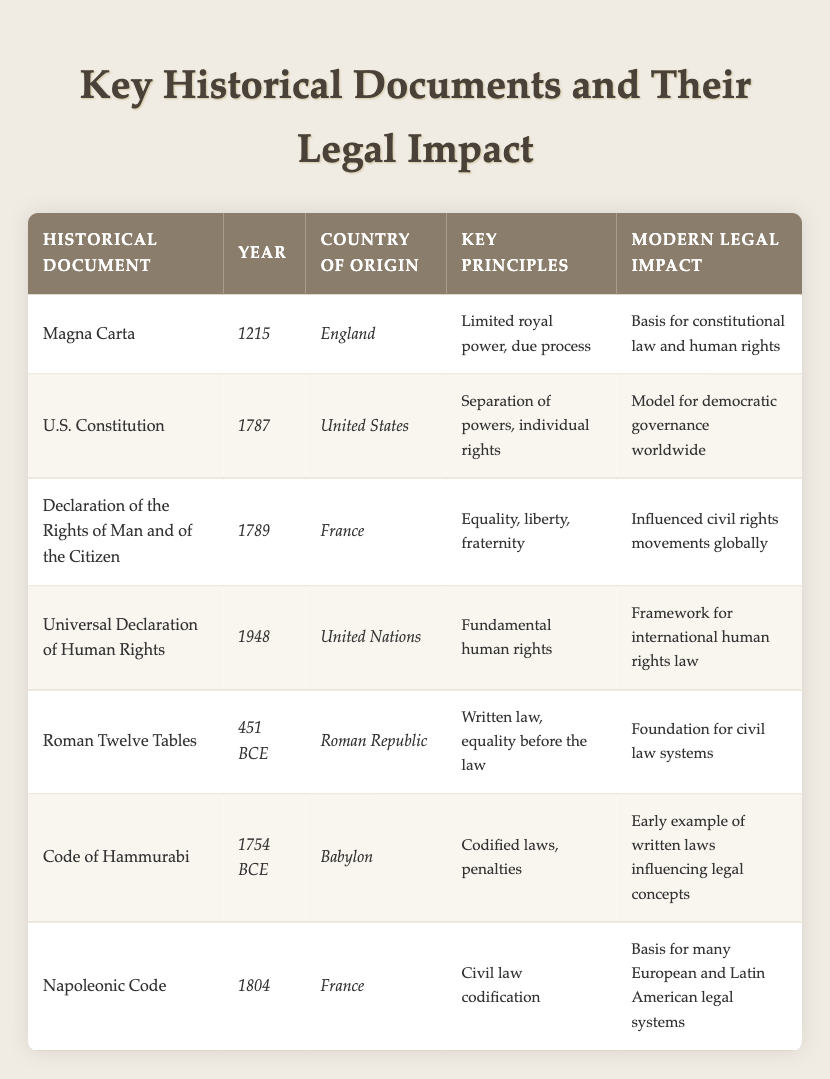What year was the Magna Carta signed? The table states that the Magna Carta was signed in 1215 under the "Year" column.
Answer: 1215 Which document is considered the basis for constitutional law and human rights? According to the "Modern Legal Impact" column, the Magna Carta is regarded as the basis for constitutional law and human rights.
Answer: Magna Carta What are the key principles of the U.S. Constitution? The "Key Principles" column shows that the U.S. Constitution is characterized by the separation of powers and individual rights.
Answer: Separation of powers, individual rights Which document was created first, the Roman Twelve Tables or the Code of Hammurabi? The table indicates that the Roman Twelve Tables were established in 451 BCE, while the Code of Hammurabi was created in 1754 BCE, making the Roman Twelve Tables the earlier document.
Answer: Roman Twelve Tables Does the Universal Declaration of Human Rights originate from the United Nations? The "Country of Origin" column specifies that the Universal Declaration of Human Rights was indeed established by the United Nations, confirming the statement as true.
Answer: Yes What is the modern legal impact of the Napoleonic Code? The table states under "Modern Legal Impact" that the Napoleonic Code serves as the basis for many European and Latin American legal systems.
Answer: Basis for many European and Latin American legal systems Which document includes the principle of equality before the law? The "Key Principles" column shows that the Roman Twelve Tables include the principle of equality before the law.
Answer: Roman Twelve Tables How many historical documents listed originated from France? By looking at the "Country of Origin" column, we see the Declaration of the Rights of Man and of the Citizen and the Napoleonic Code both originate from France, totaling two documents.
Answer: 2 What are the founding principles of the Declaration of the Rights of Man and of the Citizen? The "Key Principles" column indicates that the founding principles include equality, liberty, and fraternity.
Answer: Equality, liberty, fraternity Is the U.S. Constitution considered a model for democratic governance worldwide? The table indicates that the U.S. Constitution has this important impact listed under "Modern Legal Impact," confirming the statement as true.
Answer: Yes 